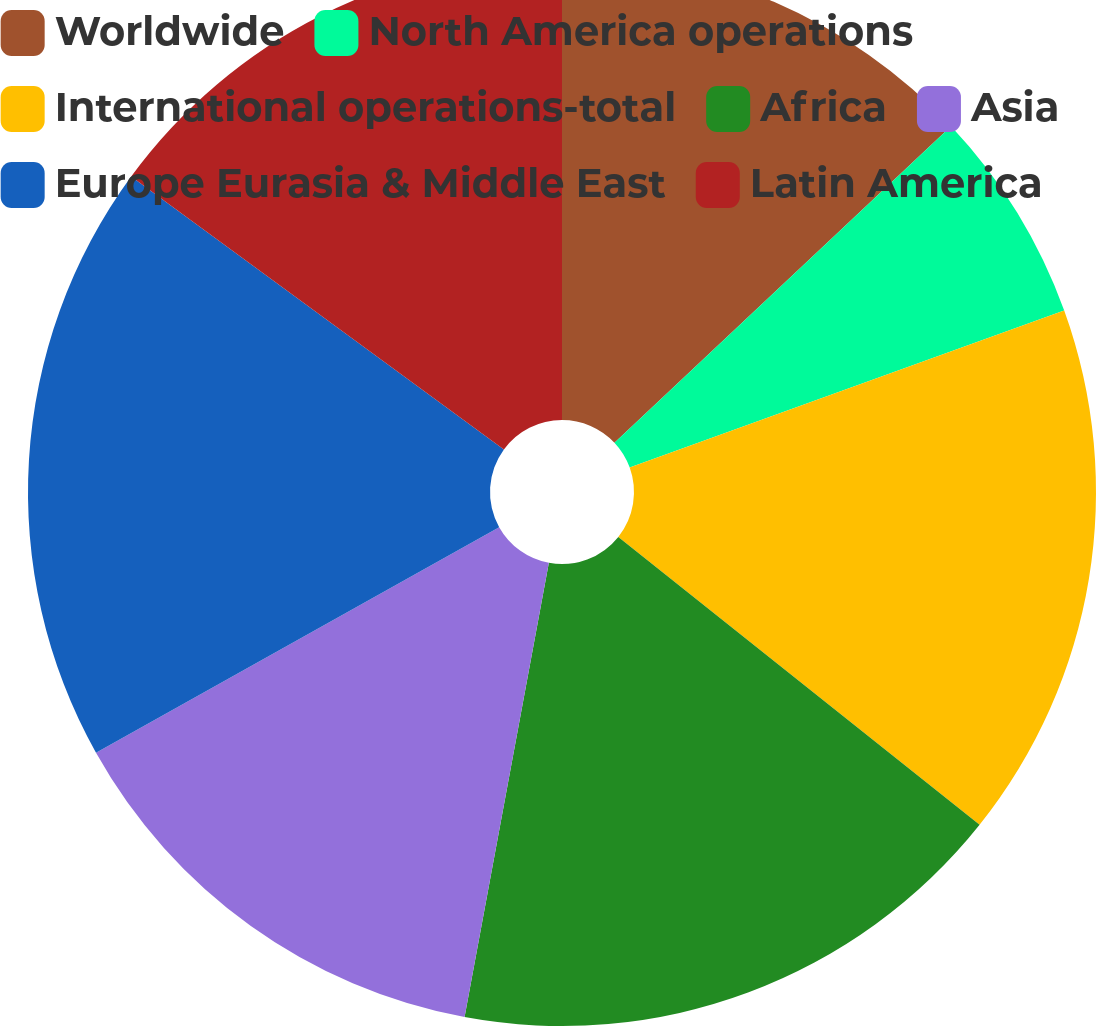<chart> <loc_0><loc_0><loc_500><loc_500><pie_chart><fcel>Worldwide<fcel>North America operations<fcel>International operations-total<fcel>Africa<fcel>Asia<fcel>Europe Eurasia & Middle East<fcel>Latin America<nl><fcel>12.99%<fcel>6.49%<fcel>16.23%<fcel>17.21%<fcel>13.96%<fcel>18.18%<fcel>14.94%<nl></chart> 